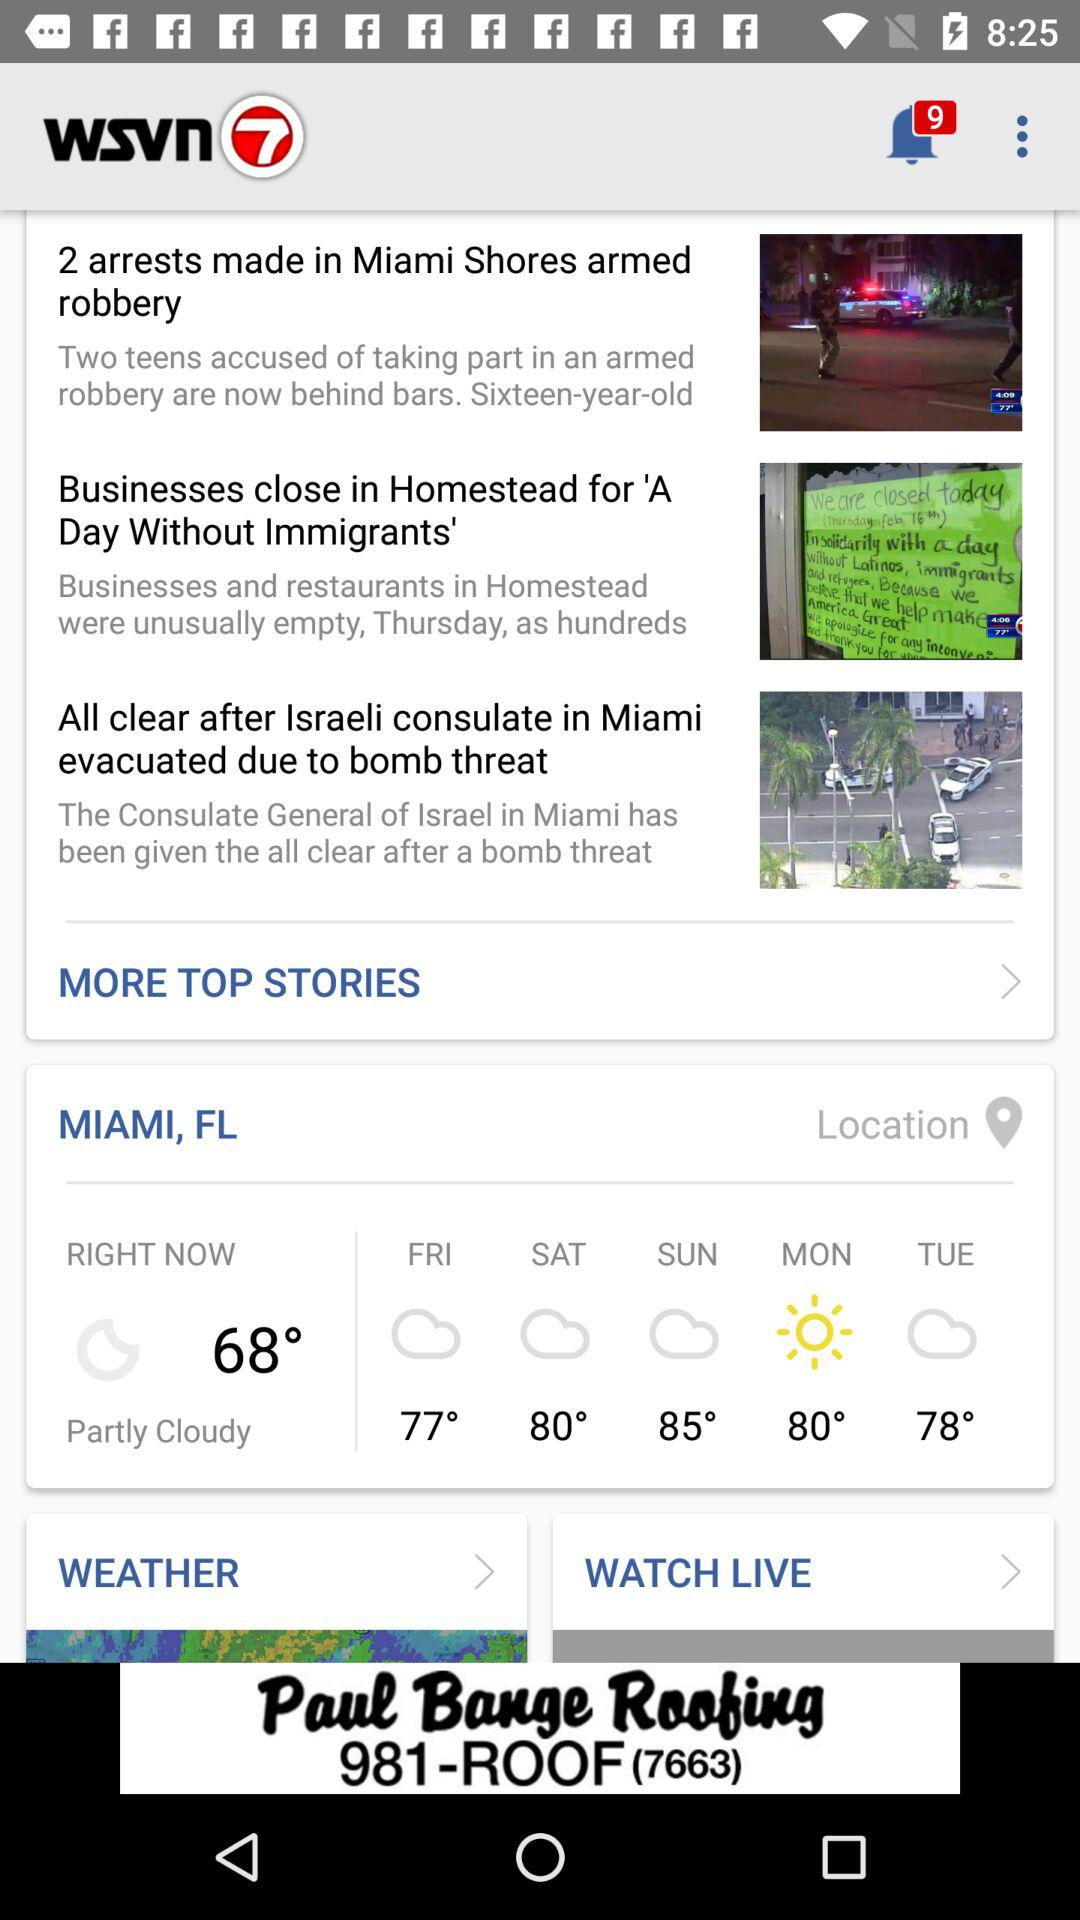How is the weather right now? Right now, the weather is partly cloudy. 